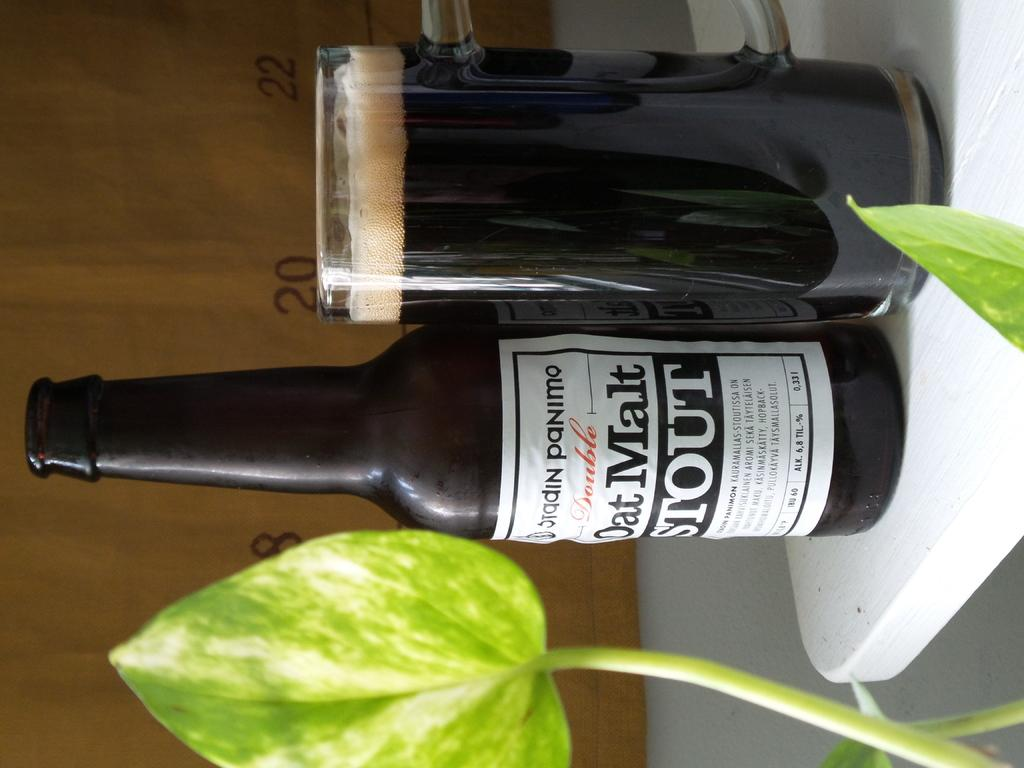<image>
Present a compact description of the photo's key features. A bottle of Oat Moat stout stands on a white table next to a full glass of the same liquid. 